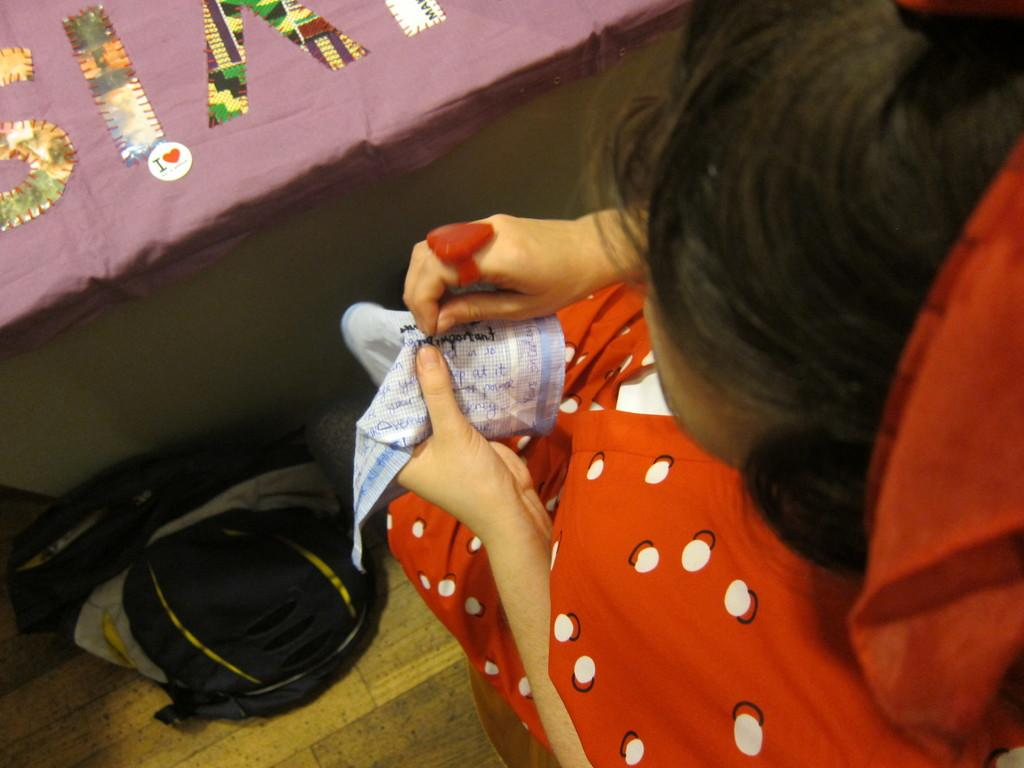Who is present in the image? There is a woman in the image. What is the woman holding in the image? The woman is holding a cloth. What is on the floor in the image? There is a bag on the floor in the image. What is on the cloth in the image? There are cards on the cloth in the image. Where is the cloth located in the image? The cloth is on a table in the image. What type of salt is being used to play with the cards in the image? There is no salt present in the image, and the cards are not being used for playing. 